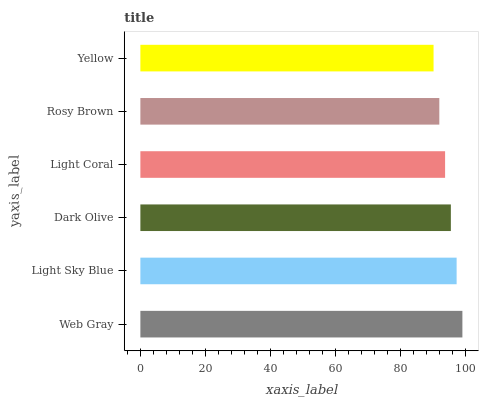Is Yellow the minimum?
Answer yes or no. Yes. Is Web Gray the maximum?
Answer yes or no. Yes. Is Light Sky Blue the minimum?
Answer yes or no. No. Is Light Sky Blue the maximum?
Answer yes or no. No. Is Web Gray greater than Light Sky Blue?
Answer yes or no. Yes. Is Light Sky Blue less than Web Gray?
Answer yes or no. Yes. Is Light Sky Blue greater than Web Gray?
Answer yes or no. No. Is Web Gray less than Light Sky Blue?
Answer yes or no. No. Is Dark Olive the high median?
Answer yes or no. Yes. Is Light Coral the low median?
Answer yes or no. Yes. Is Light Sky Blue the high median?
Answer yes or no. No. Is Rosy Brown the low median?
Answer yes or no. No. 